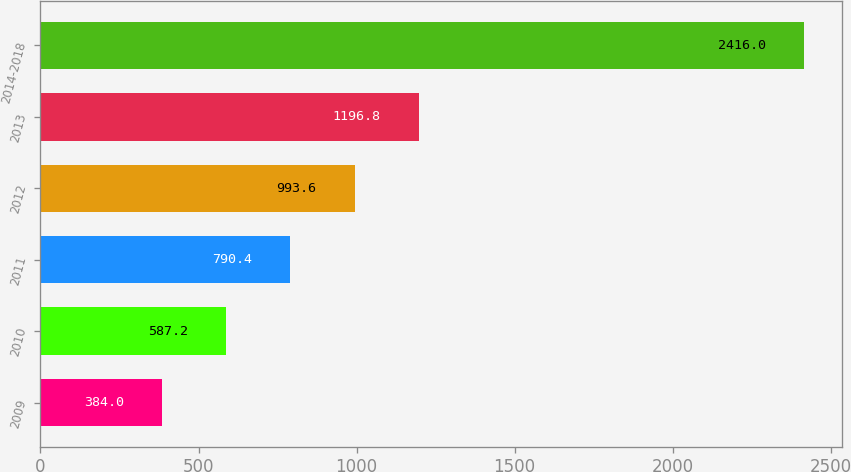Convert chart. <chart><loc_0><loc_0><loc_500><loc_500><bar_chart><fcel>2009<fcel>2010<fcel>2011<fcel>2012<fcel>2013<fcel>2014-2018<nl><fcel>384<fcel>587.2<fcel>790.4<fcel>993.6<fcel>1196.8<fcel>2416<nl></chart> 